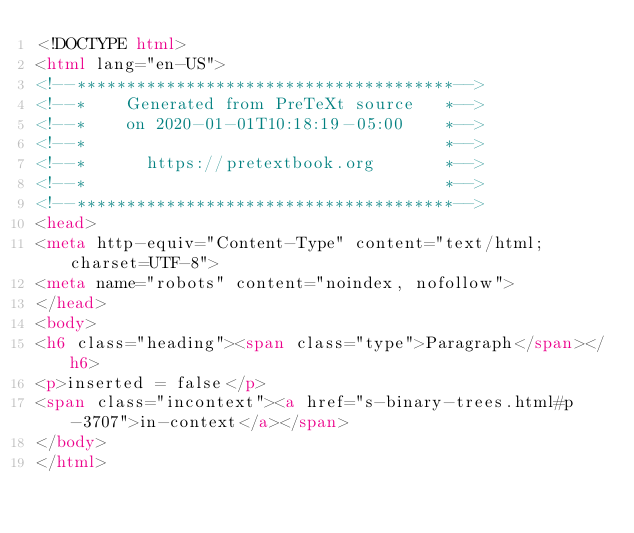<code> <loc_0><loc_0><loc_500><loc_500><_HTML_><!DOCTYPE html>
<html lang="en-US">
<!--**************************************-->
<!--*    Generated from PreTeXt source   *-->
<!--*    on 2020-01-01T10:18:19-05:00    *-->
<!--*                                    *-->
<!--*      https://pretextbook.org       *-->
<!--*                                    *-->
<!--**************************************-->
<head>
<meta http-equiv="Content-Type" content="text/html; charset=UTF-8">
<meta name="robots" content="noindex, nofollow">
</head>
<body>
<h6 class="heading"><span class="type">Paragraph</span></h6>
<p>inserted = false</p>
<span class="incontext"><a href="s-binary-trees.html#p-3707">in-context</a></span>
</body>
</html>
</code> 